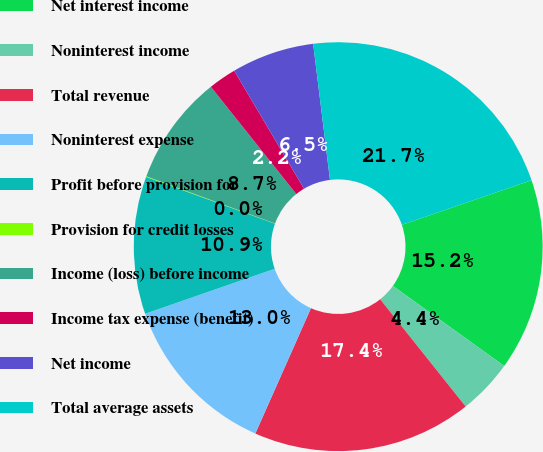Convert chart. <chart><loc_0><loc_0><loc_500><loc_500><pie_chart><fcel>Net interest income<fcel>Noninterest income<fcel>Total revenue<fcel>Noninterest expense<fcel>Profit before provision for<fcel>Provision for credit losses<fcel>Income (loss) before income<fcel>Income tax expense (benefit)<fcel>Net income<fcel>Total average assets<nl><fcel>15.19%<fcel>4.37%<fcel>17.36%<fcel>13.03%<fcel>10.87%<fcel>0.05%<fcel>8.7%<fcel>2.21%<fcel>6.54%<fcel>21.69%<nl></chart> 